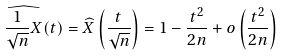Convert formula to latex. <formula><loc_0><loc_0><loc_500><loc_500>\widehat { \frac { 1 } { \sqrt { n } } X } ( t ) = \widehat { X } \left ( \frac { t } { \sqrt { n } } \right ) = 1 - \frac { t ^ { 2 } } { 2 n } + o \left ( \frac { t ^ { 2 } } { 2 n } \right )</formula> 